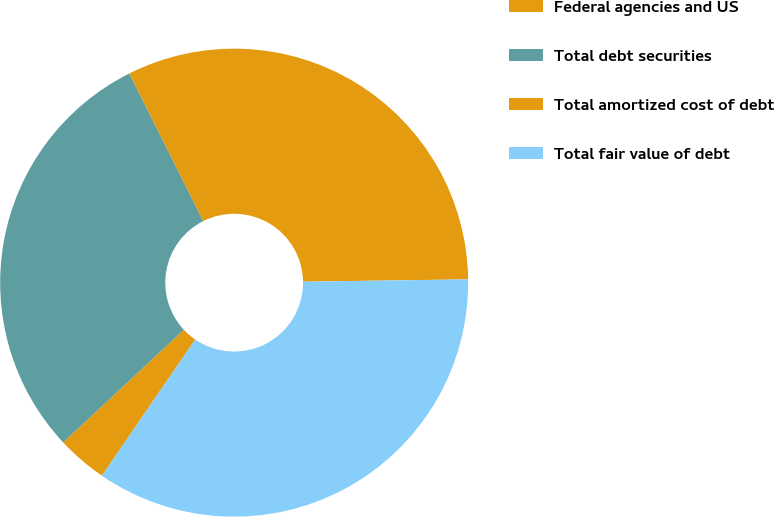<chart> <loc_0><loc_0><loc_500><loc_500><pie_chart><fcel>Federal agencies and US<fcel>Total debt securities<fcel>Total amortized cost of debt<fcel>Total fair value of debt<nl><fcel>3.48%<fcel>29.57%<fcel>32.17%<fcel>34.78%<nl></chart> 